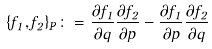<formula> <loc_0><loc_0><loc_500><loc_500>\{ f _ { 1 } , f _ { 2 } \} _ { P } \colon = \frac { \partial f _ { 1 } } { \partial q } \frac { \partial f _ { 2 } } { \partial p } - \frac { \partial f _ { 1 } } { \partial p } \frac { \partial f _ { 2 } } { \partial q }</formula> 